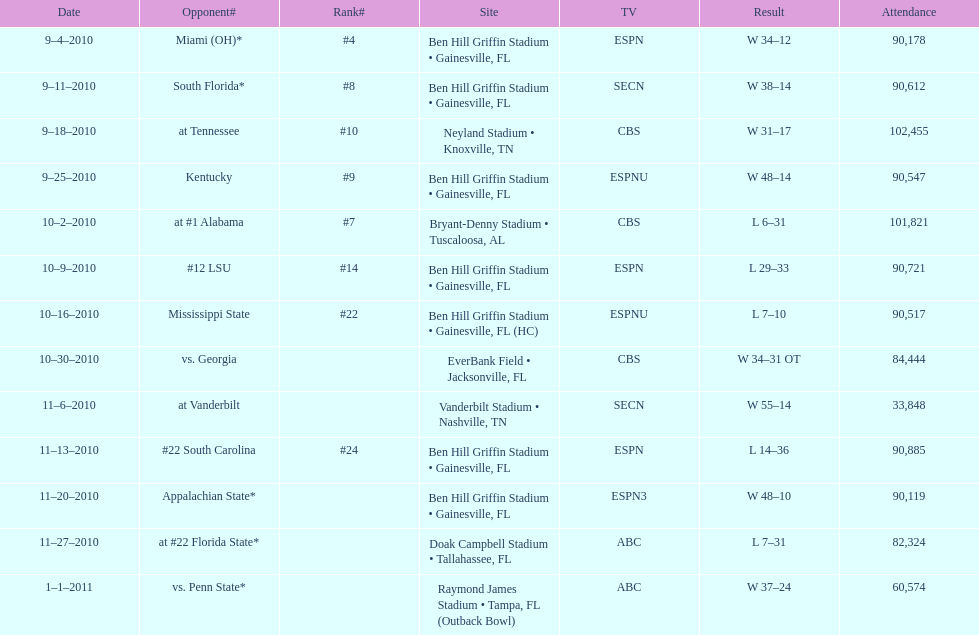The gators won the game on september 25, 2010. who won the previous game? Gators. 